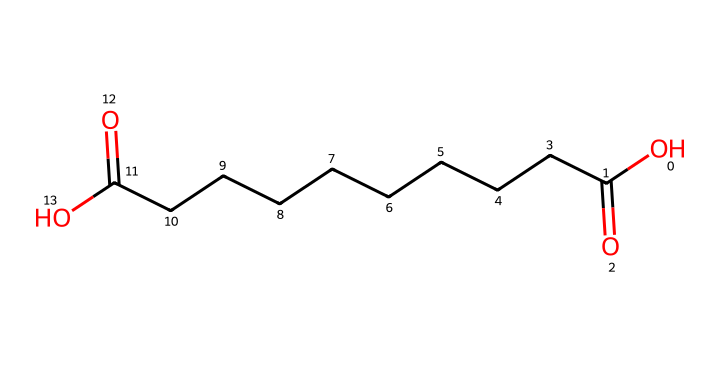What is the total number of carbon atoms in azelaic acid? In the SMILES representation, we can count the number of carbon (C) atoms from the sequence of Cs. There are 9 carbon atoms in the main carbon chain of azelaic acid.
Answer: nine How many functional groups are present in azelaic acid? The SMILES shows two -COOH (carboxylic acid) functional groups, indicating that there are two functional groups in the molecule.
Answer: two What is the molecular formula of azelaic acid? Based on the count of atoms shown in the SMILES, the molecule consists of 9 carbon, 16 hydrogen, and 4 oxygen atoms, leading to the molecular formula C9H16O4.
Answer: C9H16O4 What type of acid is azelaic acid? The presence of two -COOH groups in the structure classifies it as a dicarboxylic acid.
Answer: dicarboxylic acid How is the symmetry in azelaic acid important? The symmetry of the long carbon chain and functional groups allows for a uniform distribution of the chemical properties and reactivity, making it suitable for use in skin treatments.
Answer: symmetry What does the presence of the two carboxylic acid groups suggest about azelaic acid's solubility? The two carboxylic acid groups increase the molecule's polarity, which suggests that it has enhanced solubility in water due to hydrogen bonding capabilities.
Answer: enhanced solubility 